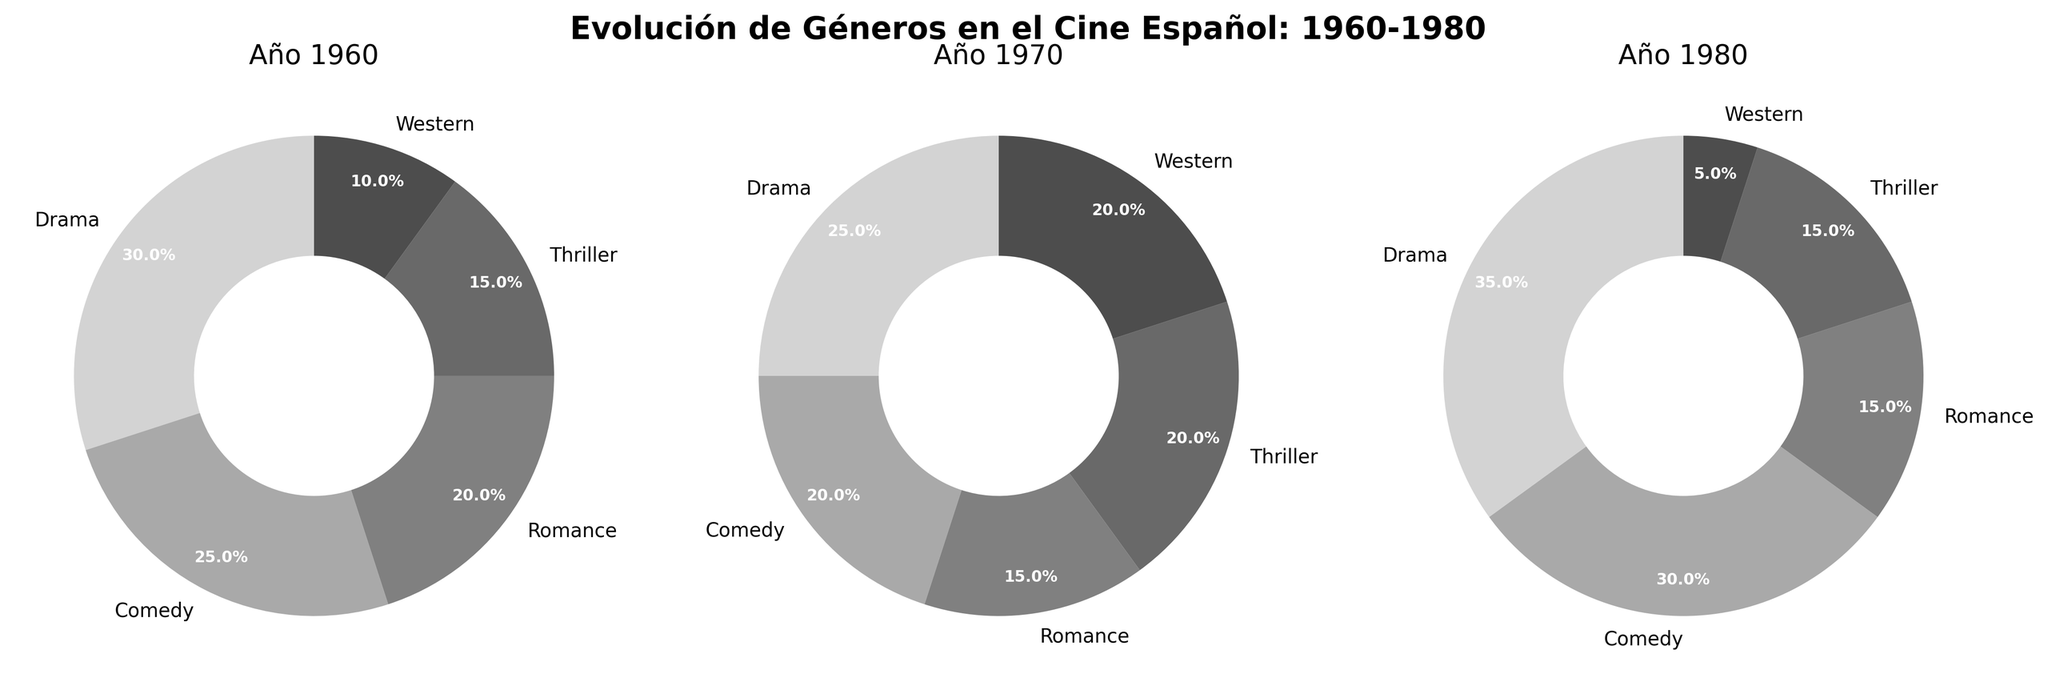What year had the highest percentage of Drama movies? Scan each pie chart’s sector labeled “Drama” and find the year with the highest percentage. The 1980 pie chart shows the highest percentage for Drama at 35%.
Answer: 1980 How did the percentage of Western movies change from 1960 to 1980? Look at the wedge labeled “Western” in the pie charts for 1960, 1970, and 1980. Western movies went from 10% in 1960 to 20% in 1970, then down to 5% in 1980.
Answer: Decreased What genre saw the biggest increase in percentage from 1960 to 1980? Compare the percentages for each genre between 1960 and 1980. Drama increased from 30% in 1960 to 35% in 1980, the largest increase of all the genres.
Answer: Drama Which genres had a higher percentage in 1960 compared to 1980? Compare the percentages for each genre between 1960 and 1980. Both Western and Thriller had higher percentages in 1960 (10% and 15%, respectively) compared to 1980 (5% and 15%).
Answer: Western, Thriller What was the percentage difference in Comedy movies between 1960 and 1980? Locate the wedge for Comedy in 1960 (25%) and in 1980 (30%), and calculate the difference: 30% - 25% = 5%.
Answer: 5% Which year had the least variety of movie genres based on equal distribution percentages? Observe the distribution uniformity in each pie chart. Equal distribution implies percentages close to equal proportions. 1980 has a more varied distribution compared to 1960 and 1970, with Drama and Comedy having notably higher shares.
Answer: 1980 How did the percentage of Thriller movies change from 1960 to 1970? Analyze the pies; Thriller in 1960 had 15% and in 1970 it increased to 20%. Calculate the change: 20% - 15% = 5%.
Answer: Increased by 5% Rank the genres by their percentage in 1980. Look at the earnings listed in 1980’s pie chart: Drama (35%), Comedy (30%), Romance (15%), Thriller (15%), Western (5%).
Answer: Drama, Comedy, Romance, Thriller, Western What are the two most constant genres in terms of percentage from 1960 to 1980? Observe the consistency of percentages across the years. Romance and Thriller remain relatively stable: Romance (20%, 15%, 15%) and Thriller (15%, 20%, 15%).
Answer: Romance, Thriller What genre had the greatest percentage decline from 1960 to 1980? Compare percentages for all genres between 1960 and 1980. Western declined from 10% in 1960 to 5% in 1980, the largest drop among all genres.
Answer: Western 